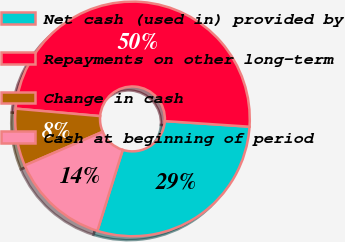<chart> <loc_0><loc_0><loc_500><loc_500><pie_chart><fcel>Net cash (used in) provided by<fcel>Repayments on other long-term<fcel>Change in cash<fcel>Cash at beginning of period<nl><fcel>28.78%<fcel>49.66%<fcel>7.89%<fcel>13.68%<nl></chart> 